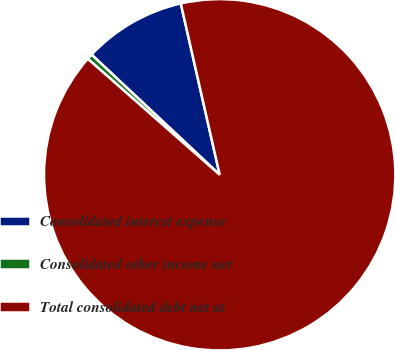Convert chart. <chart><loc_0><loc_0><loc_500><loc_500><pie_chart><fcel>Consolidated interest expense<fcel>Consolidated other income net<fcel>Total consolidated debt net at<nl><fcel>9.46%<fcel>0.51%<fcel>90.04%<nl></chart> 